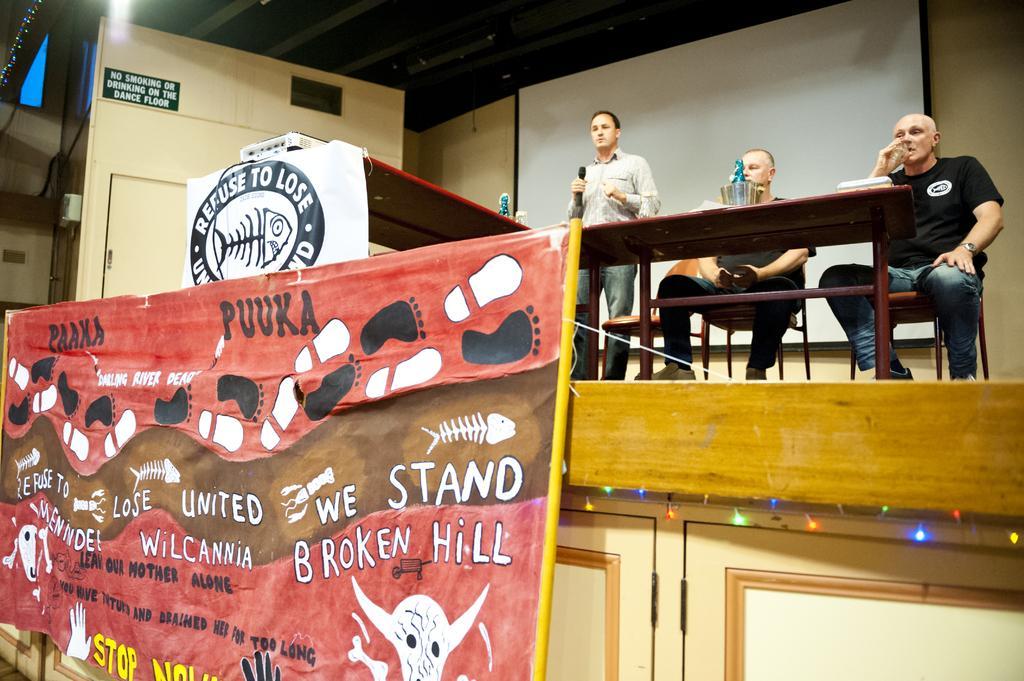Describe this image in one or two sentences. In the image there are three person ,a man is standing in front of a table ,i think he is speaking something ,other two men are sitting on chair. I think this is an auditorium. There is a banner in the left on that banner there is text. In the background there is a projector screen. 